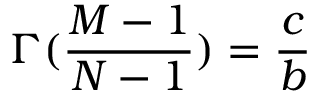<formula> <loc_0><loc_0><loc_500><loc_500>\Gamma ( \frac { M - 1 } { N - 1 } ) = \frac { c } { b }</formula> 